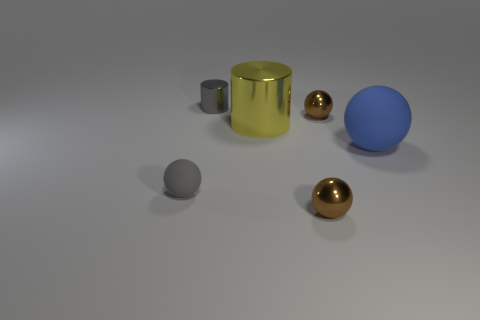How many objects are tiny balls in front of the big blue matte sphere or rubber objects?
Offer a very short reply. 3. There is a tiny gray object in front of the brown metallic ball that is behind the big yellow object; what shape is it?
Your answer should be compact. Sphere. Are there any brown metallic spheres that have the same size as the blue thing?
Your response must be concise. No. Is the number of large red metal blocks greater than the number of tiny spheres?
Ensure brevity in your answer.  No. Do the gray object in front of the blue rubber sphere and the rubber object that is on the right side of the large metal object have the same size?
Give a very brief answer. No. How many small things are both right of the gray sphere and in front of the large blue rubber sphere?
Offer a terse response. 1. There is another thing that is the same shape as the small gray metallic object; what is its color?
Your response must be concise. Yellow. Are there fewer metal balls than gray cylinders?
Provide a succinct answer. No. There is a gray shiny thing; is it the same size as the brown thing that is behind the large yellow thing?
Your answer should be compact. Yes. What color is the matte thing left of the brown sphere that is in front of the blue matte thing?
Provide a succinct answer. Gray. 